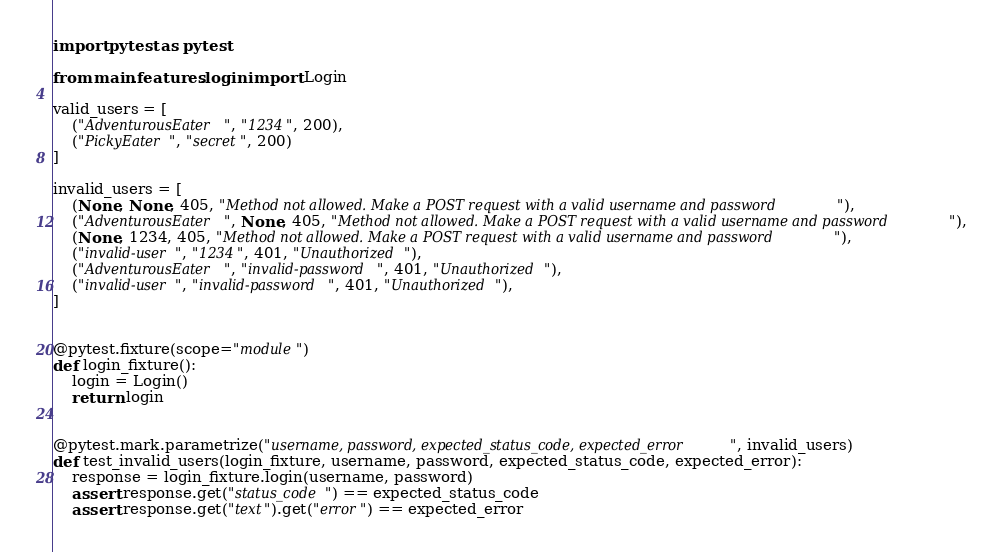Convert code to text. <code><loc_0><loc_0><loc_500><loc_500><_Python_>import pytest as pytest

from main.features.login import Login

valid_users = [
    ("AdventurousEater", "1234", 200),
    ("PickyEater", "secret", 200)
]

invalid_users = [
    (None, None, 405, "Method not allowed. Make a POST request with a valid username and password"),
    ("AdventurousEater", None, 405, "Method not allowed. Make a POST request with a valid username and password"),
    (None, 1234, 405, "Method not allowed. Make a POST request with a valid username and password"),
    ("invalid-user", "1234", 401, "Unauthorized"),
    ("AdventurousEater", "invalid-password", 401, "Unauthorized"),
    ("invalid-user", "invalid-password", 401, "Unauthorized"),
]


@pytest.fixture(scope="module")
def login_fixture():
    login = Login()
    return login


@pytest.mark.parametrize("username, password, expected_status_code, expected_error", invalid_users)
def test_invalid_users(login_fixture, username, password, expected_status_code, expected_error):
    response = login_fixture.login(username, password)
    assert response.get("status_code") == expected_status_code
    assert response.get("text").get("error") == expected_error

</code> 